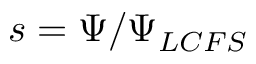<formula> <loc_0><loc_0><loc_500><loc_500>s = \Psi / \Psi _ { L C F S }</formula> 